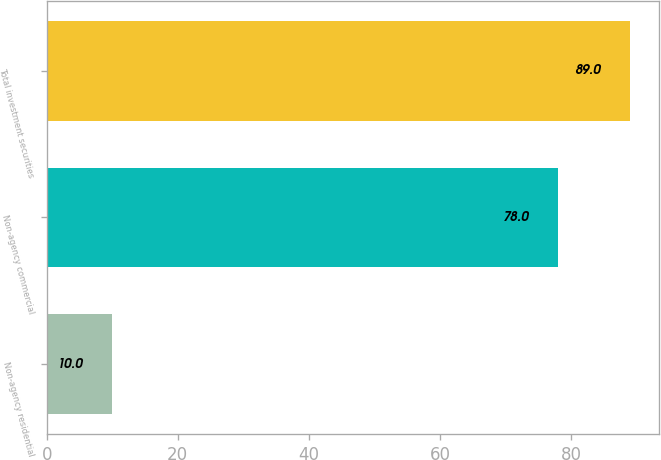<chart> <loc_0><loc_0><loc_500><loc_500><bar_chart><fcel>Non-agency residential<fcel>Non-agency commercial<fcel>Total investment securities<nl><fcel>10<fcel>78<fcel>89<nl></chart> 